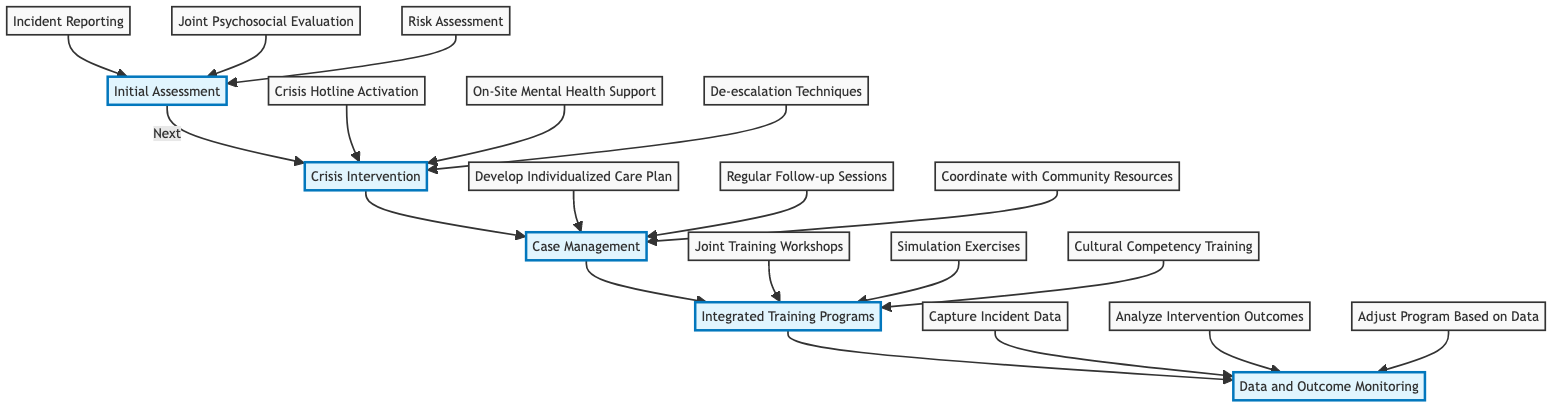What is the first step in the Clinical Pathway? The diagram indicates that the first step is "Initial Assessment," which is the first node mentioned in the flow of the pathway.
Answer: Initial Assessment How many elements are in the pathway? By counting the distinct elements in the diagram, we find there are five main elements: Initial Assessment, Crisis Intervention, Case Management, Integrated Training Programs, and Data and Outcome Monitoring.
Answer: Five What follows after Crisis Intervention? According to the flow of the pathway, the next step after Crisis Intervention is Case Management, which connects directly to Crisis Intervention in the diagram.
Answer: Case Management What is the last step in the Clinical Pathway? The final element in the pathway is Data and Outcome Monitoring, as indicated by its position at the end of the flow.
Answer: Data and Outcome Monitoring Which component involves "Joint Training Workshops"? The "Joint Training Workshops" is a part of the Integrated Training Programs section, as it is included in the steps listed under that element in the diagram.
Answer: Integrated Training Programs How many steps are in Case Management? Looking at the diagram, Case Management has three steps: Develop Individualized Care Plan, Regular Follow-up Sessions, and Coordinate with Community Resources.
Answer: Three What is the relationship between Initial Assessment and Crisis Intervention? Initial Assessment leads directly to Crisis Intervention, showing a clear path in the flow of the diagram where one step transitions to the next.
Answer: Leads to Which step involves "Crisis Hotline Activation"? The "Crisis Hotline Activation" is a step found under the Crisis Intervention element of the pathway, indicating where it is situated in the flow.
Answer: Crisis Intervention How do Data and Outcome Monitoring improve the Clinical Pathway? Data and Outcome Monitoring inform the pathway by capturing incident data, analyzing intervention outcomes, and adjusting the program based on data gathered, thus ensuring continuous improvement.
Answer: Continuous improvement 